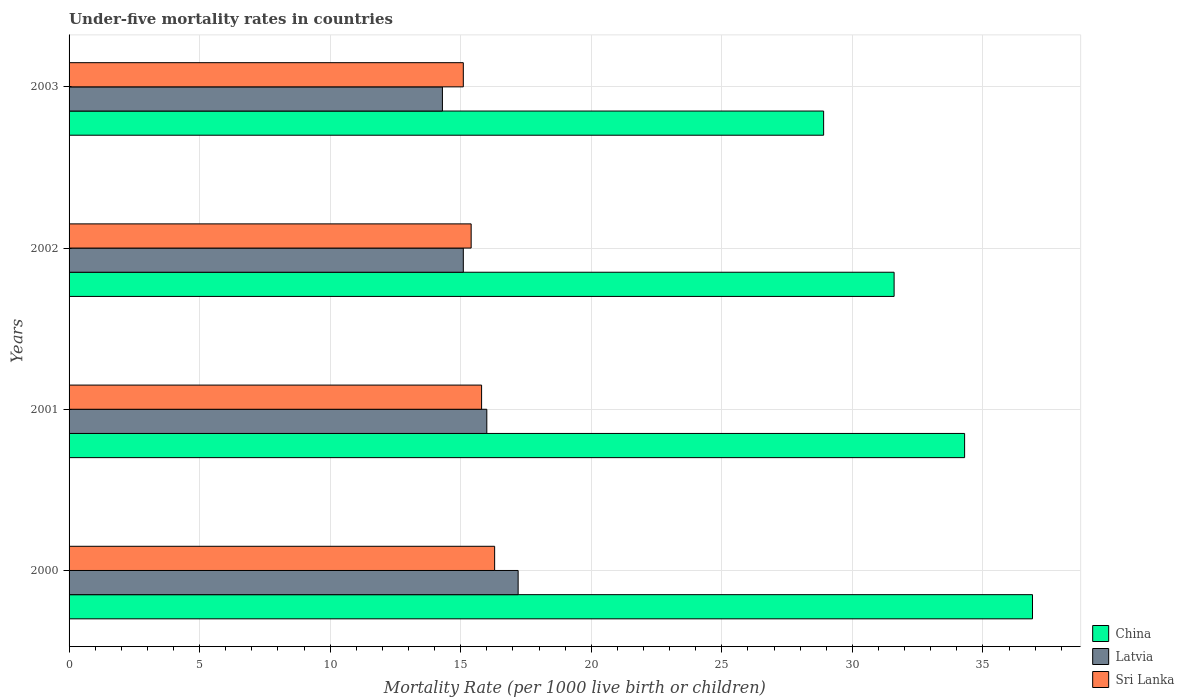How many different coloured bars are there?
Ensure brevity in your answer.  3. Are the number of bars on each tick of the Y-axis equal?
Offer a terse response. Yes. How many bars are there on the 4th tick from the top?
Provide a short and direct response. 3. What is the under-five mortality rate in Sri Lanka in 2001?
Your response must be concise. 15.8. In which year was the under-five mortality rate in Latvia maximum?
Provide a succinct answer. 2000. What is the total under-five mortality rate in China in the graph?
Make the answer very short. 131.7. What is the difference between the under-five mortality rate in China in 2001 and that in 2003?
Your answer should be compact. 5.4. What is the difference between the under-five mortality rate in Sri Lanka in 2000 and the under-five mortality rate in Latvia in 2002?
Your answer should be very brief. 1.2. What is the average under-five mortality rate in China per year?
Your answer should be very brief. 32.92. In the year 2003, what is the difference between the under-five mortality rate in Latvia and under-five mortality rate in Sri Lanka?
Your answer should be very brief. -0.8. What is the ratio of the under-five mortality rate in China in 2000 to that in 2003?
Keep it short and to the point. 1.28. Is the under-five mortality rate in Sri Lanka in 2002 less than that in 2003?
Provide a short and direct response. No. Is the difference between the under-five mortality rate in Latvia in 2000 and 2002 greater than the difference between the under-five mortality rate in Sri Lanka in 2000 and 2002?
Your answer should be compact. Yes. What is the difference between the highest and the lowest under-five mortality rate in Latvia?
Keep it short and to the point. 2.9. In how many years, is the under-five mortality rate in Latvia greater than the average under-five mortality rate in Latvia taken over all years?
Give a very brief answer. 2. Is the sum of the under-five mortality rate in Sri Lanka in 2000 and 2001 greater than the maximum under-five mortality rate in Latvia across all years?
Make the answer very short. Yes. What does the 1st bar from the top in 2003 represents?
Keep it short and to the point. Sri Lanka. What does the 2nd bar from the bottom in 2002 represents?
Your response must be concise. Latvia. How many bars are there?
Ensure brevity in your answer.  12. How many years are there in the graph?
Your response must be concise. 4. Are the values on the major ticks of X-axis written in scientific E-notation?
Your answer should be very brief. No. Does the graph contain grids?
Keep it short and to the point. Yes. Where does the legend appear in the graph?
Your answer should be compact. Bottom right. How many legend labels are there?
Your answer should be very brief. 3. What is the title of the graph?
Your answer should be very brief. Under-five mortality rates in countries. Does "Timor-Leste" appear as one of the legend labels in the graph?
Ensure brevity in your answer.  No. What is the label or title of the X-axis?
Your response must be concise. Mortality Rate (per 1000 live birth or children). What is the label or title of the Y-axis?
Make the answer very short. Years. What is the Mortality Rate (per 1000 live birth or children) of China in 2000?
Your response must be concise. 36.9. What is the Mortality Rate (per 1000 live birth or children) in Latvia in 2000?
Keep it short and to the point. 17.2. What is the Mortality Rate (per 1000 live birth or children) in China in 2001?
Offer a very short reply. 34.3. What is the Mortality Rate (per 1000 live birth or children) of Latvia in 2001?
Offer a very short reply. 16. What is the Mortality Rate (per 1000 live birth or children) of Sri Lanka in 2001?
Your answer should be very brief. 15.8. What is the Mortality Rate (per 1000 live birth or children) in China in 2002?
Your response must be concise. 31.6. What is the Mortality Rate (per 1000 live birth or children) in Latvia in 2002?
Provide a short and direct response. 15.1. What is the Mortality Rate (per 1000 live birth or children) of Sri Lanka in 2002?
Your response must be concise. 15.4. What is the Mortality Rate (per 1000 live birth or children) in China in 2003?
Make the answer very short. 28.9. What is the Mortality Rate (per 1000 live birth or children) in Latvia in 2003?
Make the answer very short. 14.3. What is the Mortality Rate (per 1000 live birth or children) in Sri Lanka in 2003?
Ensure brevity in your answer.  15.1. Across all years, what is the maximum Mortality Rate (per 1000 live birth or children) in China?
Offer a very short reply. 36.9. Across all years, what is the maximum Mortality Rate (per 1000 live birth or children) of Latvia?
Your response must be concise. 17.2. Across all years, what is the minimum Mortality Rate (per 1000 live birth or children) of China?
Give a very brief answer. 28.9. Across all years, what is the minimum Mortality Rate (per 1000 live birth or children) of Latvia?
Offer a terse response. 14.3. Across all years, what is the minimum Mortality Rate (per 1000 live birth or children) in Sri Lanka?
Offer a terse response. 15.1. What is the total Mortality Rate (per 1000 live birth or children) of China in the graph?
Offer a very short reply. 131.7. What is the total Mortality Rate (per 1000 live birth or children) of Latvia in the graph?
Your answer should be compact. 62.6. What is the total Mortality Rate (per 1000 live birth or children) in Sri Lanka in the graph?
Your answer should be compact. 62.6. What is the difference between the Mortality Rate (per 1000 live birth or children) of China in 2000 and that in 2001?
Offer a very short reply. 2.6. What is the difference between the Mortality Rate (per 1000 live birth or children) of Sri Lanka in 2000 and that in 2001?
Offer a terse response. 0.5. What is the difference between the Mortality Rate (per 1000 live birth or children) in Sri Lanka in 2000 and that in 2002?
Provide a short and direct response. 0.9. What is the difference between the Mortality Rate (per 1000 live birth or children) in China in 2000 and that in 2003?
Offer a very short reply. 8. What is the difference between the Mortality Rate (per 1000 live birth or children) in Latvia in 2000 and that in 2003?
Give a very brief answer. 2.9. What is the difference between the Mortality Rate (per 1000 live birth or children) in Sri Lanka in 2000 and that in 2003?
Keep it short and to the point. 1.2. What is the difference between the Mortality Rate (per 1000 live birth or children) in China in 2001 and that in 2002?
Ensure brevity in your answer.  2.7. What is the difference between the Mortality Rate (per 1000 live birth or children) in Latvia in 2001 and that in 2002?
Keep it short and to the point. 0.9. What is the difference between the Mortality Rate (per 1000 live birth or children) of Sri Lanka in 2001 and that in 2002?
Offer a terse response. 0.4. What is the difference between the Mortality Rate (per 1000 live birth or children) in Sri Lanka in 2001 and that in 2003?
Provide a short and direct response. 0.7. What is the difference between the Mortality Rate (per 1000 live birth or children) in Sri Lanka in 2002 and that in 2003?
Provide a succinct answer. 0.3. What is the difference between the Mortality Rate (per 1000 live birth or children) in China in 2000 and the Mortality Rate (per 1000 live birth or children) in Latvia in 2001?
Provide a succinct answer. 20.9. What is the difference between the Mortality Rate (per 1000 live birth or children) of China in 2000 and the Mortality Rate (per 1000 live birth or children) of Sri Lanka in 2001?
Your answer should be very brief. 21.1. What is the difference between the Mortality Rate (per 1000 live birth or children) in China in 2000 and the Mortality Rate (per 1000 live birth or children) in Latvia in 2002?
Offer a very short reply. 21.8. What is the difference between the Mortality Rate (per 1000 live birth or children) of China in 2000 and the Mortality Rate (per 1000 live birth or children) of Latvia in 2003?
Keep it short and to the point. 22.6. What is the difference between the Mortality Rate (per 1000 live birth or children) of China in 2000 and the Mortality Rate (per 1000 live birth or children) of Sri Lanka in 2003?
Make the answer very short. 21.8. What is the difference between the Mortality Rate (per 1000 live birth or children) of China in 2001 and the Mortality Rate (per 1000 live birth or children) of Latvia in 2002?
Your response must be concise. 19.2. What is the difference between the Mortality Rate (per 1000 live birth or children) of China in 2001 and the Mortality Rate (per 1000 live birth or children) of Sri Lanka in 2002?
Make the answer very short. 18.9. What is the difference between the Mortality Rate (per 1000 live birth or children) in Latvia in 2001 and the Mortality Rate (per 1000 live birth or children) in Sri Lanka in 2002?
Make the answer very short. 0.6. What is the difference between the Mortality Rate (per 1000 live birth or children) of China in 2001 and the Mortality Rate (per 1000 live birth or children) of Latvia in 2003?
Give a very brief answer. 20. What is the difference between the Mortality Rate (per 1000 live birth or children) of China in 2002 and the Mortality Rate (per 1000 live birth or children) of Latvia in 2003?
Your answer should be very brief. 17.3. What is the difference between the Mortality Rate (per 1000 live birth or children) of Latvia in 2002 and the Mortality Rate (per 1000 live birth or children) of Sri Lanka in 2003?
Make the answer very short. 0. What is the average Mortality Rate (per 1000 live birth or children) in China per year?
Offer a terse response. 32.92. What is the average Mortality Rate (per 1000 live birth or children) of Latvia per year?
Make the answer very short. 15.65. What is the average Mortality Rate (per 1000 live birth or children) of Sri Lanka per year?
Ensure brevity in your answer.  15.65. In the year 2000, what is the difference between the Mortality Rate (per 1000 live birth or children) in China and Mortality Rate (per 1000 live birth or children) in Sri Lanka?
Your answer should be compact. 20.6. In the year 2000, what is the difference between the Mortality Rate (per 1000 live birth or children) of Latvia and Mortality Rate (per 1000 live birth or children) of Sri Lanka?
Make the answer very short. 0.9. In the year 2001, what is the difference between the Mortality Rate (per 1000 live birth or children) in China and Mortality Rate (per 1000 live birth or children) in Latvia?
Offer a terse response. 18.3. In the year 2001, what is the difference between the Mortality Rate (per 1000 live birth or children) in China and Mortality Rate (per 1000 live birth or children) in Sri Lanka?
Provide a succinct answer. 18.5. In the year 2003, what is the difference between the Mortality Rate (per 1000 live birth or children) in China and Mortality Rate (per 1000 live birth or children) in Sri Lanka?
Give a very brief answer. 13.8. In the year 2003, what is the difference between the Mortality Rate (per 1000 live birth or children) in Latvia and Mortality Rate (per 1000 live birth or children) in Sri Lanka?
Your answer should be very brief. -0.8. What is the ratio of the Mortality Rate (per 1000 live birth or children) in China in 2000 to that in 2001?
Provide a short and direct response. 1.08. What is the ratio of the Mortality Rate (per 1000 live birth or children) of Latvia in 2000 to that in 2001?
Your answer should be very brief. 1.07. What is the ratio of the Mortality Rate (per 1000 live birth or children) of Sri Lanka in 2000 to that in 2001?
Offer a very short reply. 1.03. What is the ratio of the Mortality Rate (per 1000 live birth or children) in China in 2000 to that in 2002?
Give a very brief answer. 1.17. What is the ratio of the Mortality Rate (per 1000 live birth or children) in Latvia in 2000 to that in 2002?
Offer a terse response. 1.14. What is the ratio of the Mortality Rate (per 1000 live birth or children) in Sri Lanka in 2000 to that in 2002?
Give a very brief answer. 1.06. What is the ratio of the Mortality Rate (per 1000 live birth or children) of China in 2000 to that in 2003?
Give a very brief answer. 1.28. What is the ratio of the Mortality Rate (per 1000 live birth or children) in Latvia in 2000 to that in 2003?
Make the answer very short. 1.2. What is the ratio of the Mortality Rate (per 1000 live birth or children) of Sri Lanka in 2000 to that in 2003?
Offer a very short reply. 1.08. What is the ratio of the Mortality Rate (per 1000 live birth or children) in China in 2001 to that in 2002?
Give a very brief answer. 1.09. What is the ratio of the Mortality Rate (per 1000 live birth or children) of Latvia in 2001 to that in 2002?
Ensure brevity in your answer.  1.06. What is the ratio of the Mortality Rate (per 1000 live birth or children) of Sri Lanka in 2001 to that in 2002?
Provide a succinct answer. 1.03. What is the ratio of the Mortality Rate (per 1000 live birth or children) of China in 2001 to that in 2003?
Provide a succinct answer. 1.19. What is the ratio of the Mortality Rate (per 1000 live birth or children) of Latvia in 2001 to that in 2003?
Offer a terse response. 1.12. What is the ratio of the Mortality Rate (per 1000 live birth or children) of Sri Lanka in 2001 to that in 2003?
Give a very brief answer. 1.05. What is the ratio of the Mortality Rate (per 1000 live birth or children) in China in 2002 to that in 2003?
Your answer should be compact. 1.09. What is the ratio of the Mortality Rate (per 1000 live birth or children) of Latvia in 2002 to that in 2003?
Your response must be concise. 1.06. What is the ratio of the Mortality Rate (per 1000 live birth or children) of Sri Lanka in 2002 to that in 2003?
Keep it short and to the point. 1.02. What is the difference between the highest and the second highest Mortality Rate (per 1000 live birth or children) in China?
Your answer should be compact. 2.6. What is the difference between the highest and the second highest Mortality Rate (per 1000 live birth or children) in Sri Lanka?
Your answer should be very brief. 0.5. 